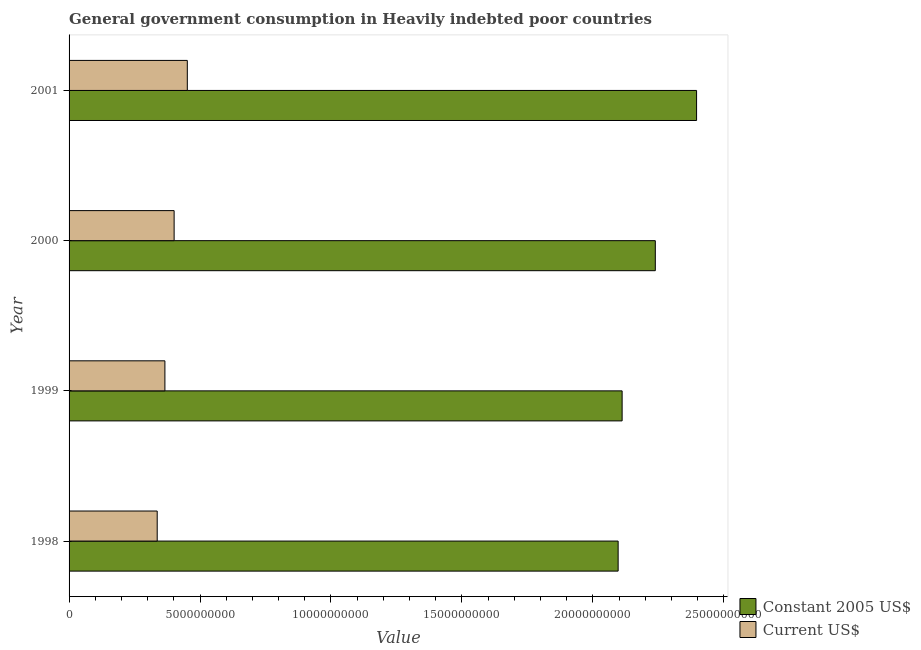How many groups of bars are there?
Provide a short and direct response. 4. Are the number of bars per tick equal to the number of legend labels?
Offer a very short reply. Yes. Are the number of bars on each tick of the Y-axis equal?
Ensure brevity in your answer.  Yes. How many bars are there on the 3rd tick from the top?
Provide a short and direct response. 2. What is the label of the 4th group of bars from the top?
Provide a succinct answer. 1998. What is the value consumed in current us$ in 2000?
Offer a very short reply. 4.01e+09. Across all years, what is the maximum value consumed in current us$?
Your answer should be very brief. 4.51e+09. Across all years, what is the minimum value consumed in current us$?
Provide a succinct answer. 3.37e+09. In which year was the value consumed in current us$ minimum?
Offer a very short reply. 1998. What is the total value consumed in constant 2005 us$ in the graph?
Your response must be concise. 8.84e+1. What is the difference between the value consumed in current us$ in 1999 and that in 2000?
Keep it short and to the point. -3.52e+08. What is the difference between the value consumed in current us$ in 1998 and the value consumed in constant 2005 us$ in 2001?
Keep it short and to the point. -2.06e+1. What is the average value consumed in constant 2005 us$ per year?
Make the answer very short. 2.21e+1. In the year 1998, what is the difference between the value consumed in current us$ and value consumed in constant 2005 us$?
Provide a succinct answer. -1.76e+1. What is the ratio of the value consumed in current us$ in 1999 to that in 2001?
Offer a very short reply. 0.81. Is the value consumed in constant 2005 us$ in 1998 less than that in 1999?
Your answer should be very brief. Yes. Is the difference between the value consumed in current us$ in 1999 and 2001 greater than the difference between the value consumed in constant 2005 us$ in 1999 and 2001?
Your response must be concise. Yes. What is the difference between the highest and the second highest value consumed in constant 2005 us$?
Ensure brevity in your answer.  1.58e+09. What is the difference between the highest and the lowest value consumed in constant 2005 us$?
Your response must be concise. 2.99e+09. Is the sum of the value consumed in current us$ in 1998 and 2001 greater than the maximum value consumed in constant 2005 us$ across all years?
Give a very brief answer. No. What does the 1st bar from the top in 2000 represents?
Ensure brevity in your answer.  Current US$. What does the 2nd bar from the bottom in 1999 represents?
Your answer should be very brief. Current US$. How many bars are there?
Your answer should be compact. 8. Are all the bars in the graph horizontal?
Keep it short and to the point. Yes. How many years are there in the graph?
Provide a short and direct response. 4. What is the difference between two consecutive major ticks on the X-axis?
Make the answer very short. 5.00e+09. Does the graph contain grids?
Your answer should be very brief. No. How are the legend labels stacked?
Offer a terse response. Vertical. What is the title of the graph?
Offer a terse response. General government consumption in Heavily indebted poor countries. Does "Time to import" appear as one of the legend labels in the graph?
Your answer should be very brief. No. What is the label or title of the X-axis?
Provide a short and direct response. Value. What is the label or title of the Y-axis?
Your response must be concise. Year. What is the Value of Constant 2005 US$ in 1998?
Your response must be concise. 2.10e+1. What is the Value of Current US$ in 1998?
Make the answer very short. 3.37e+09. What is the Value in Constant 2005 US$ in 1999?
Keep it short and to the point. 2.11e+1. What is the Value in Current US$ in 1999?
Your answer should be very brief. 3.66e+09. What is the Value of Constant 2005 US$ in 2000?
Your response must be concise. 2.24e+1. What is the Value of Current US$ in 2000?
Make the answer very short. 4.01e+09. What is the Value in Constant 2005 US$ in 2001?
Ensure brevity in your answer.  2.40e+1. What is the Value of Current US$ in 2001?
Keep it short and to the point. 4.51e+09. Across all years, what is the maximum Value in Constant 2005 US$?
Make the answer very short. 2.40e+1. Across all years, what is the maximum Value of Current US$?
Ensure brevity in your answer.  4.51e+09. Across all years, what is the minimum Value of Constant 2005 US$?
Your answer should be very brief. 2.10e+1. Across all years, what is the minimum Value in Current US$?
Make the answer very short. 3.37e+09. What is the total Value of Constant 2005 US$ in the graph?
Your answer should be compact. 8.84e+1. What is the total Value in Current US$ in the graph?
Your response must be concise. 1.56e+1. What is the difference between the Value in Constant 2005 US$ in 1998 and that in 1999?
Make the answer very short. -1.52e+08. What is the difference between the Value in Current US$ in 1998 and that in 1999?
Your response must be concise. -2.94e+08. What is the difference between the Value in Constant 2005 US$ in 1998 and that in 2000?
Provide a short and direct response. -1.42e+09. What is the difference between the Value of Current US$ in 1998 and that in 2000?
Ensure brevity in your answer.  -6.46e+08. What is the difference between the Value of Constant 2005 US$ in 1998 and that in 2001?
Your answer should be compact. -2.99e+09. What is the difference between the Value in Current US$ in 1998 and that in 2001?
Make the answer very short. -1.15e+09. What is the difference between the Value of Constant 2005 US$ in 1999 and that in 2000?
Give a very brief answer. -1.27e+09. What is the difference between the Value in Current US$ in 1999 and that in 2000?
Make the answer very short. -3.52e+08. What is the difference between the Value of Constant 2005 US$ in 1999 and that in 2001?
Offer a very short reply. -2.84e+09. What is the difference between the Value in Current US$ in 1999 and that in 2001?
Offer a terse response. -8.56e+08. What is the difference between the Value of Constant 2005 US$ in 2000 and that in 2001?
Offer a terse response. -1.58e+09. What is the difference between the Value of Current US$ in 2000 and that in 2001?
Your response must be concise. -5.04e+08. What is the difference between the Value of Constant 2005 US$ in 1998 and the Value of Current US$ in 1999?
Provide a short and direct response. 1.73e+1. What is the difference between the Value in Constant 2005 US$ in 1998 and the Value in Current US$ in 2000?
Ensure brevity in your answer.  1.70e+1. What is the difference between the Value of Constant 2005 US$ in 1998 and the Value of Current US$ in 2001?
Your answer should be very brief. 1.65e+1. What is the difference between the Value in Constant 2005 US$ in 1999 and the Value in Current US$ in 2000?
Provide a succinct answer. 1.71e+1. What is the difference between the Value of Constant 2005 US$ in 1999 and the Value of Current US$ in 2001?
Your answer should be very brief. 1.66e+1. What is the difference between the Value of Constant 2005 US$ in 2000 and the Value of Current US$ in 2001?
Give a very brief answer. 1.79e+1. What is the average Value in Constant 2005 US$ per year?
Offer a terse response. 2.21e+1. What is the average Value of Current US$ per year?
Keep it short and to the point. 3.89e+09. In the year 1998, what is the difference between the Value in Constant 2005 US$ and Value in Current US$?
Your answer should be very brief. 1.76e+1. In the year 1999, what is the difference between the Value of Constant 2005 US$ and Value of Current US$?
Make the answer very short. 1.75e+1. In the year 2000, what is the difference between the Value of Constant 2005 US$ and Value of Current US$?
Ensure brevity in your answer.  1.84e+1. In the year 2001, what is the difference between the Value in Constant 2005 US$ and Value in Current US$?
Your answer should be very brief. 1.94e+1. What is the ratio of the Value in Current US$ in 1998 to that in 1999?
Provide a succinct answer. 0.92. What is the ratio of the Value of Constant 2005 US$ in 1998 to that in 2000?
Give a very brief answer. 0.94. What is the ratio of the Value in Current US$ in 1998 to that in 2000?
Give a very brief answer. 0.84. What is the ratio of the Value of Constant 2005 US$ in 1998 to that in 2001?
Give a very brief answer. 0.88. What is the ratio of the Value of Current US$ in 1998 to that in 2001?
Offer a very short reply. 0.75. What is the ratio of the Value of Constant 2005 US$ in 1999 to that in 2000?
Ensure brevity in your answer.  0.94. What is the ratio of the Value of Current US$ in 1999 to that in 2000?
Offer a terse response. 0.91. What is the ratio of the Value of Constant 2005 US$ in 1999 to that in 2001?
Your answer should be very brief. 0.88. What is the ratio of the Value of Current US$ in 1999 to that in 2001?
Your answer should be compact. 0.81. What is the ratio of the Value in Constant 2005 US$ in 2000 to that in 2001?
Your answer should be very brief. 0.93. What is the ratio of the Value of Current US$ in 2000 to that in 2001?
Ensure brevity in your answer.  0.89. What is the difference between the highest and the second highest Value in Constant 2005 US$?
Ensure brevity in your answer.  1.58e+09. What is the difference between the highest and the second highest Value of Current US$?
Your answer should be very brief. 5.04e+08. What is the difference between the highest and the lowest Value in Constant 2005 US$?
Provide a short and direct response. 2.99e+09. What is the difference between the highest and the lowest Value in Current US$?
Give a very brief answer. 1.15e+09. 